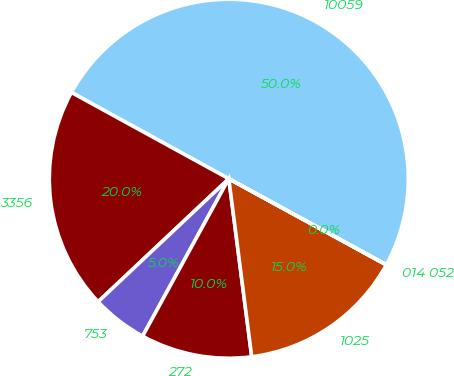Convert chart to OTSL. <chart><loc_0><loc_0><loc_500><loc_500><pie_chart><fcel>10059<fcel>3356<fcel>753<fcel>272<fcel>1025<fcel>014 052<nl><fcel>49.97%<fcel>20.0%<fcel>5.01%<fcel>10.01%<fcel>15.0%<fcel>0.01%<nl></chart> 